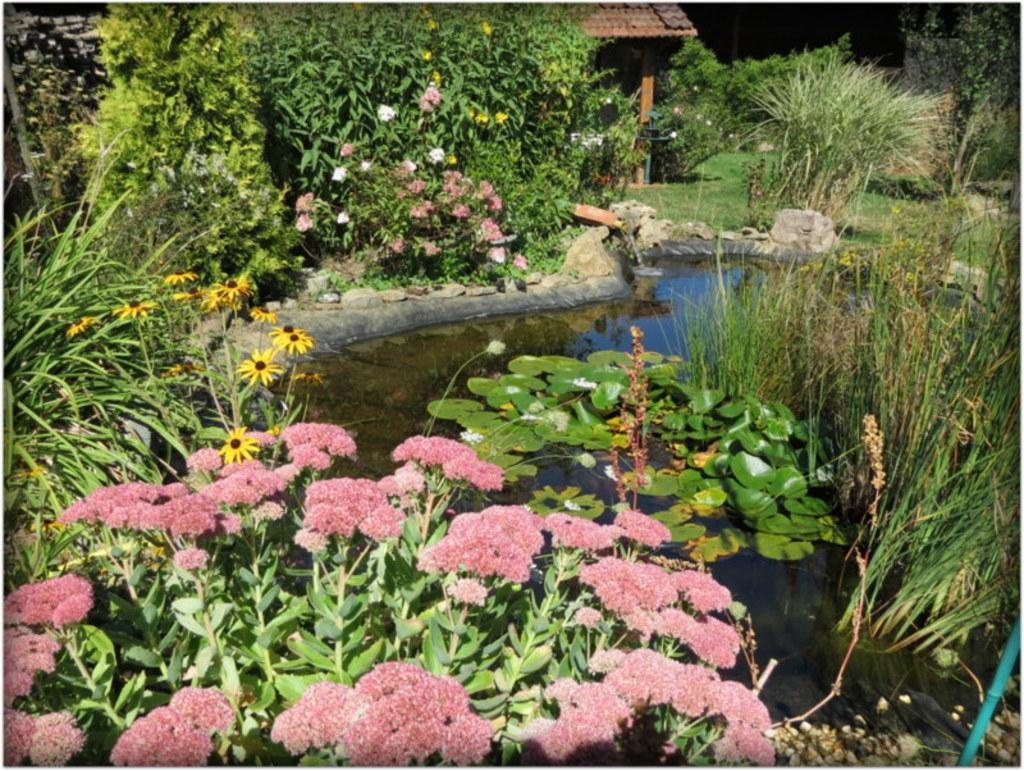What type of vegetation can be seen in the image? There are trees and plants with flowers in the image. What is the ground covered with in the image? Grass is visible on the ground in the image. What can be seen in the background of the image? There appears to be a house in the background of the image. What else is visible in the image besides vegetation and the house? There is water visible in the image. How does the ink flow in the image? There is no ink present in the image. Can you compare the size of the flowers in the image to the size of the house? It is difficult to accurately compare the size of the flowers to the size of the house without a reference point or scale in the image. 